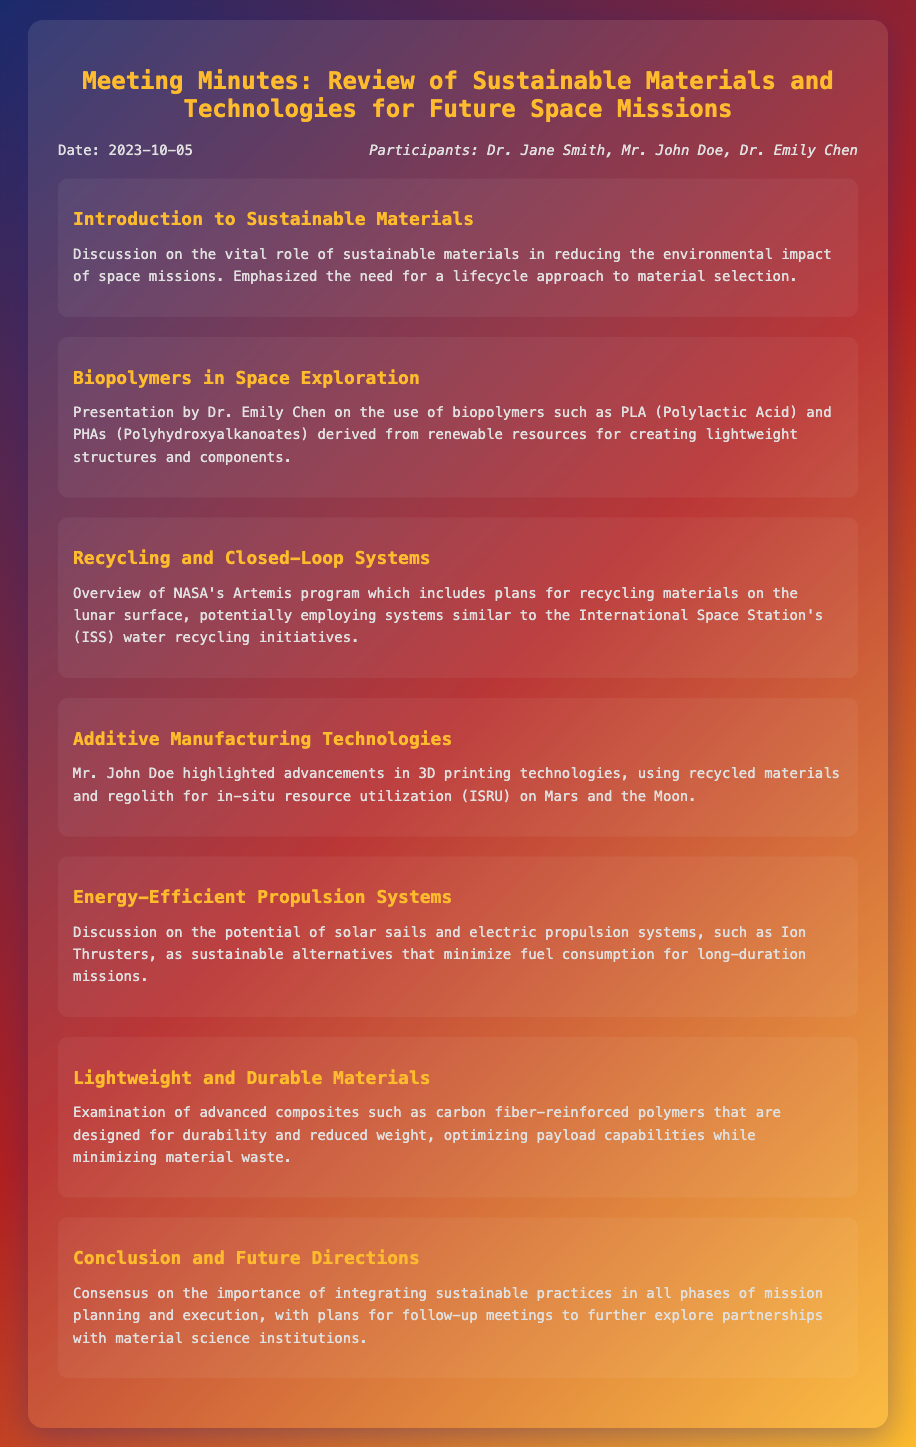What was the date of the meeting? The date of the meeting is mentioned in the document under the information section.
Answer: 2023-10-05 Who presented on the use of biopolymers? The document states that Dr. Emily Chen presented on the use of biopolymers for lightweight structures and components.
Answer: Dr. Emily Chen What is the focus of NASA's Artemis program? The document discusses NASA's Artemis program regarding recycling materials on the lunar surface.
Answer: Recycling materials on the lunar surface What materials are used in additive manufacturing technologies? The document notes the use of recycled materials and regolith in 3D printing technologies for ISRU.
Answer: Recycled materials and regolith What type of propulsion systems were discussed as sustainable alternatives? The document mentions solar sails and electric propulsion systems as sustainable propulsion alternatives.
Answer: Solar sails and electric propulsion systems What consensus was reached about sustainable practices? The conclusion highlights the importance of integrating sustainable practices in mission planning and execution.
Answer: Integrating sustainable practices in mission planning and execution Which materials were examined for their lightweight and durability? The document indicates that carbon fiber-reinforced polymers were examined for their lightweight and durable features.
Answer: Carbon fiber-reinforced polymers What is the significance of a lifecycle approach mentioned in the introduction? The introduction emphasizes the importance of a lifecycle approach to material selection in reducing environmental impact.
Answer: Reducing environmental impact 